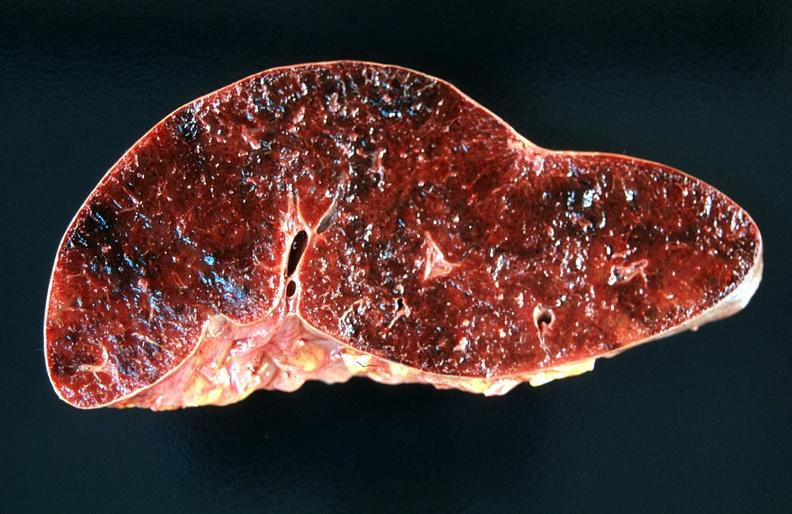what does this image show?
Answer the question using a single word or phrase. Spleen 